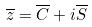Convert formula to latex. <formula><loc_0><loc_0><loc_500><loc_500>\overline { z } = \overline { C } + i \overline { S }</formula> 